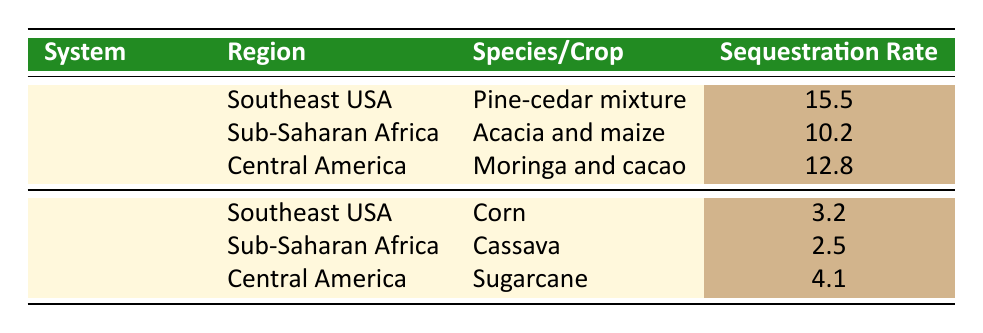What is the carbon sequestration rate for agroforestry in Southeast USA? The table states that the carbon sequestration rate for the agroforestry system in Southeast USA is specifically listed as 15.5 tonnes CO2e/ha/year.
Answer: 15.5 tonnes CO2e/ha/year What is the sequestration rate for corn in Southeast USA? According to the table, the sequestration rate for the monoculture crop corn in Southeast USA is recorded as 3.2 tonnes CO2e/ha/year.
Answer: 3.2 tonnes CO2e/ha/year Is the carbon sequestration rate for monoculture systems ever higher than for agroforestry systems? By comparing the values in the table, the highest sequestration rates for monoculture (4.1 tonnes) do not exceed those for agroforestry (15.5 tonnes). Therefore, the fact is false.
Answer: No What is the average carbon sequestration rate for agroforestry systems across the three regions listed? To calculate the average for agroforestry, add the sequestration rates: 15.5 + 10.2 + 12.8 = 38.5 tonnes. Then divide by the number of systems (3): 38.5/3 = approximately 12.83 tonnes CO2e/ha/year.
Answer: 12.83 tonnes CO2e/ha/year Which agroforestry system has the lowest carbon sequestration rate and what is its value? By examining the agroforestry rates, Acacia and maize in Sub-Saharan Africa has the lowest rate at 10.2 tonnes CO2e/ha/year.
Answer: Acacia and maize, 10.2 tonnes CO2e/ha/year What is the difference in carbon sequestration rates between the highest agroforestry and monoculture systems? The highest agroforestry rate is 15.5 tonnes from the pine-cedar mixture, and the highest monoculture rate is 4.1 tonnes from sugarcane. The difference is 15.5 - 4.1 = 11.4 tonnes CO2e/ha/year.
Answer: 11.4 tonnes CO2e/ha/year 